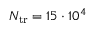<formula> <loc_0><loc_0><loc_500><loc_500>N _ { t r } = 1 5 \cdot 1 0 ^ { 4 }</formula> 